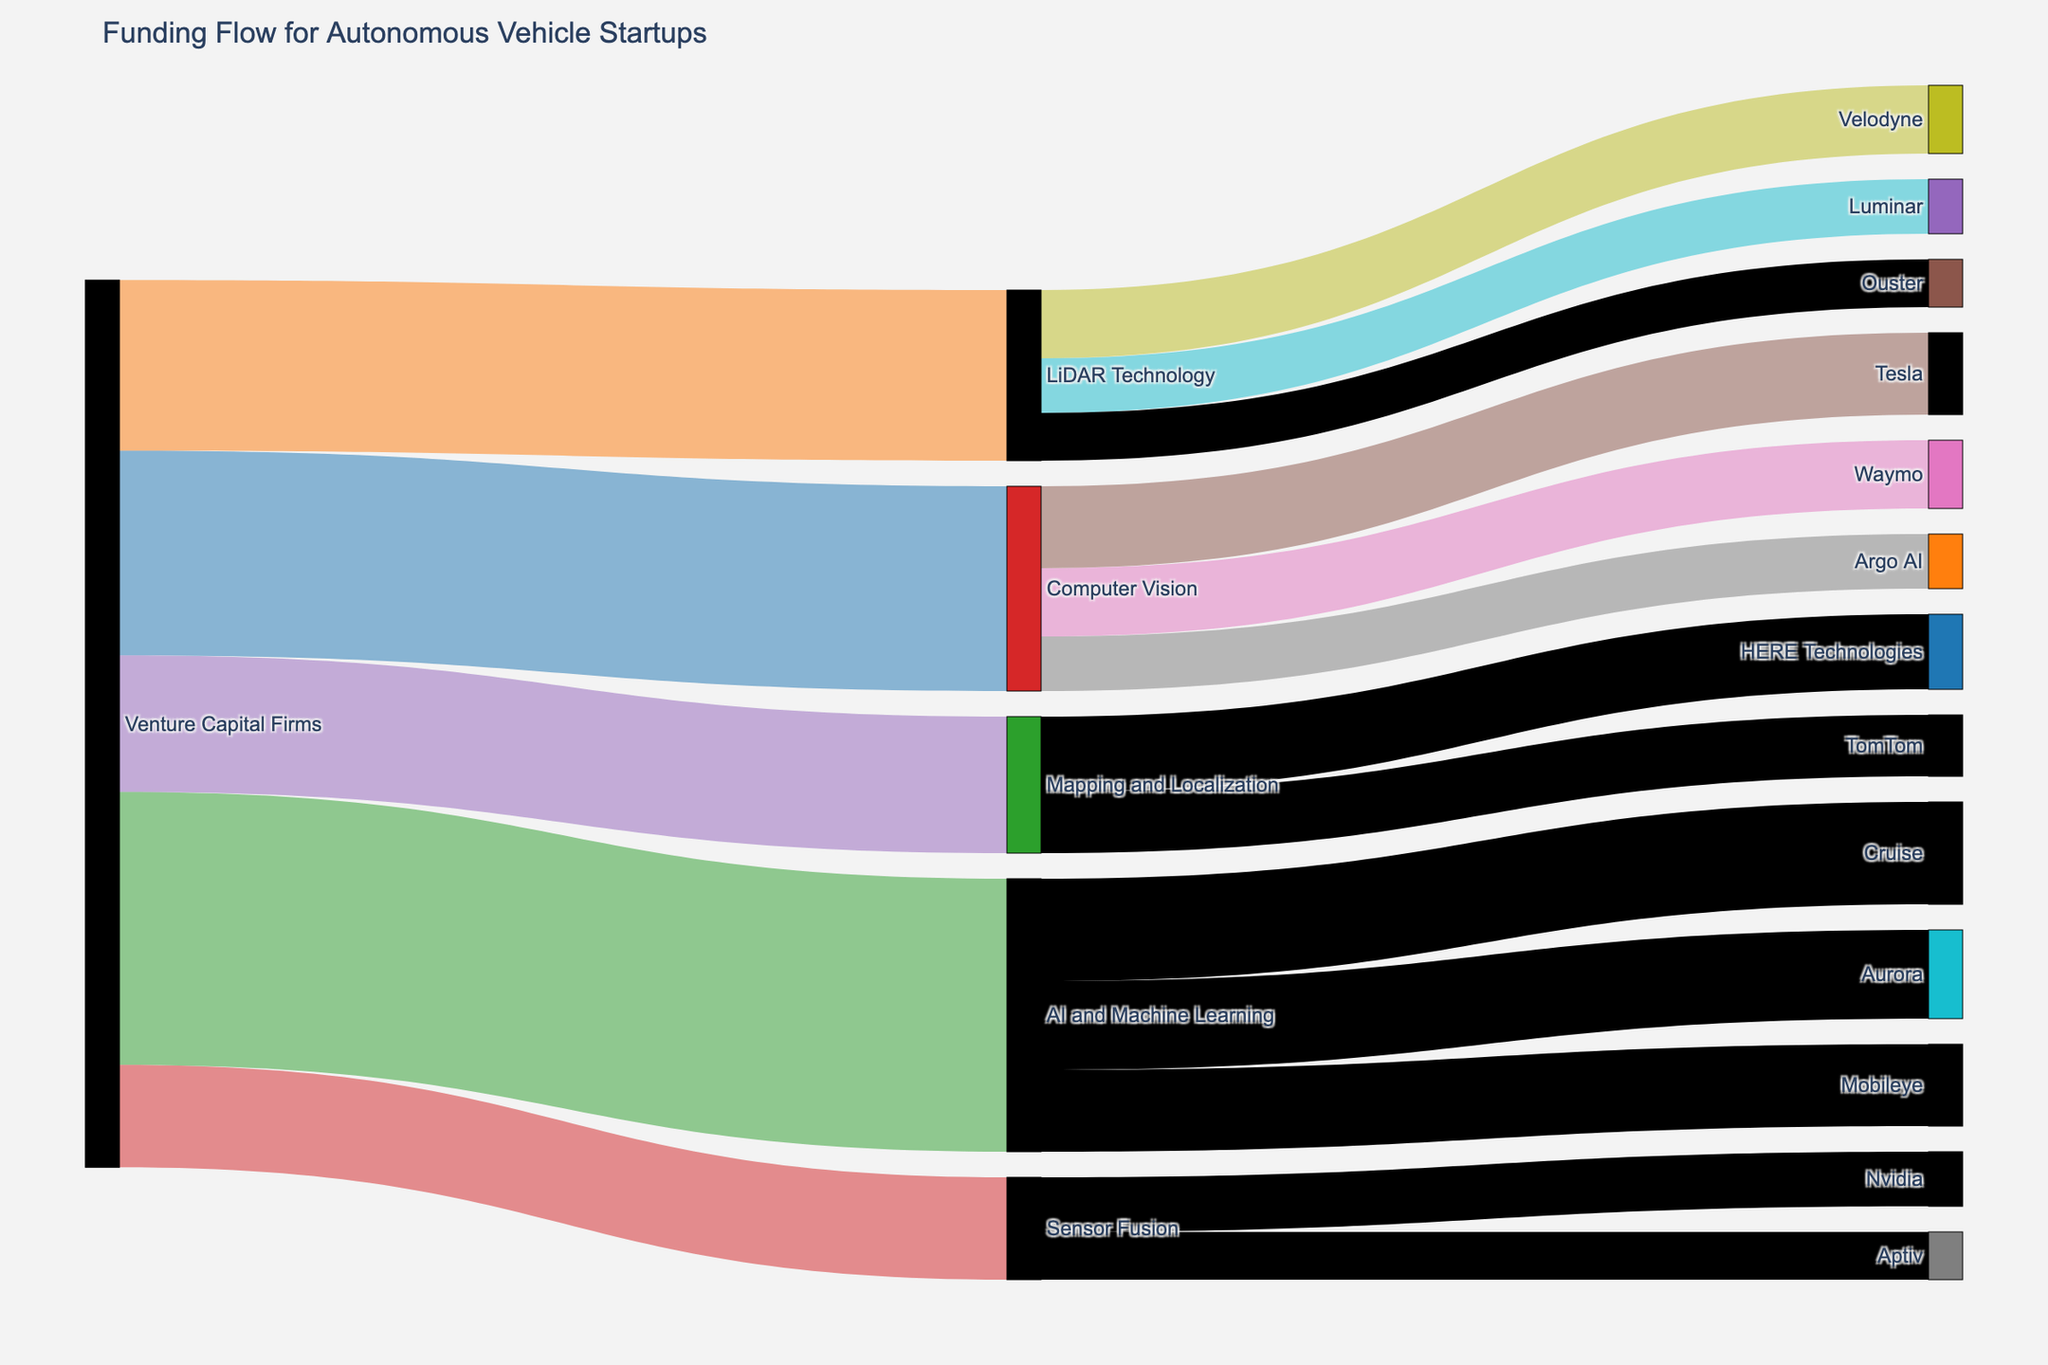What sectors receive funding from Venture Capital Firms? Look at the initial node labeled "Venture Capital Firms" and identify all outgoing links. The sectors receiving funding include Computer Vision, LiDAR Technology, AI and Machine Learning, Sensor Fusion, and Mapping and Localization.
Answer: Computer Vision, LiDAR Technology, AI and Machine Learning, Sensor Fusion, Mapping and Localization Which company receives the highest funding from AI and Machine Learning? From the "AI and Machine Learning" node, follow the links to the companies (Cruise, Aurora, and Mobileye), and compare their funding values. Cruise receives the highest amount with 150.
Answer: Cruise How much total funding is directed to Computer Vision? Sum the values of the links originating from "Computer Vision" to Tesla, Waymo, and Argo AI (120 + 100 + 80). The total is 300.
Answer: 300 Which startup receives funding from both LiDAR Technology and Sensor Fusion? Follow the outgoing links from both "LiDAR Technology" and "Sensor Fusion" nodes. No startup appears to receive funding from both concurrently.
Answer: None How does the funding for AI and Machine Learning compare to LiDAR Technology? Compare the values of links originating from "Venture Capital Firms" to "AI and Machine Learning" (400) and "LiDAR Technology" (250). AI and Machine Learning receive more funding.
Answer: AI and Machine Learning What is the total amount of venture capital distributed to all technology sectors? Add up all the funding values flowing out of "Venture Capital Firms" to the technology sectors (300 + 250 + 400 + 150 + 200). The total amount is 1300.
Answer: 1300 Which company related to Mapping and Localization receives more funding? Compare the links from "Mapping and Localization" to TomTom and HERE Technologies. HERE Technologies receives more funding with 110 compared to TomTom with 90.
Answer: HERE Technologies What's the average funding received by companies working on LiDAR Technology? Sum the values of funding received by Velodyne, Luminar, and Ouster (100 + 80 + 70), then divide by the number of companies (3). The average funding is 83.33.
Answer: 83.33 What is the total funding allocated to startups from the Computer Vision, LiDAR Technology, and Sensor Fusion sectors combined? Sum the total funding values directed to each sector (300 for Computer Vision, 250 for LiDAR Technology, 150 for Sensor Fusion). The total is 700.
Answer: 700 What is the smallest amount of funding provided to any company and to which company does it go? Identify the smallest value on the figure and the associated company. The smallest funding amount is 70, which is received by both Ouster (LiDAR Technology) and Aptiv (Sensor Fusion).
Answer: 70 (Ouster, Aptiv) 